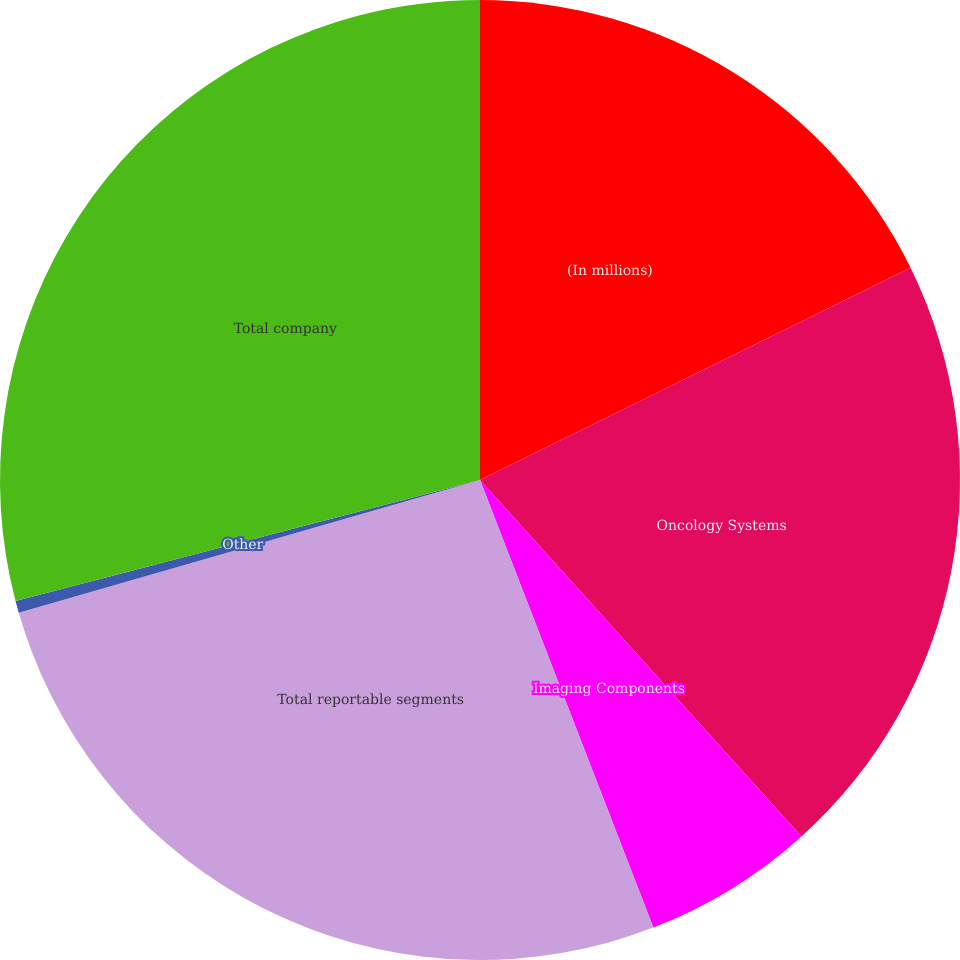Convert chart. <chart><loc_0><loc_0><loc_500><loc_500><pie_chart><fcel>(In millions)<fcel>Oncology Systems<fcel>Imaging Components<fcel>Total reportable segments<fcel>Other<fcel>Total company<nl><fcel>17.71%<fcel>20.61%<fcel>5.8%<fcel>26.42%<fcel>0.4%<fcel>29.06%<nl></chart> 